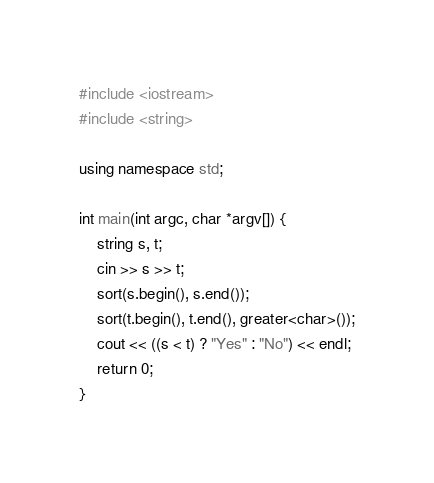<code> <loc_0><loc_0><loc_500><loc_500><_C++_>#include <iostream>
#include <string>

using namespace std;

int main(int argc, char *argv[]) {
	string s, t;
	cin >> s >> t;
	sort(s.begin(), s.end());
	sort(t.begin(), t.end(), greater<char>());
	cout << ((s < t) ? "Yes" : "No") << endl;
	return 0;
}</code> 